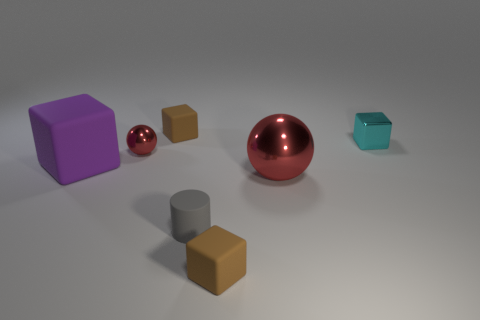Is there any other thing that has the same shape as the gray thing?
Provide a short and direct response. No. How many small brown blocks are both to the left of the cylinder and in front of the large rubber cube?
Offer a terse response. 0. What material is the large ball?
Keep it short and to the point. Metal. Are there an equal number of gray things on the right side of the gray thing and brown matte balls?
Give a very brief answer. Yes. How many other cyan objects are the same shape as the cyan object?
Your response must be concise. 0. Do the tiny gray matte object and the large metal thing have the same shape?
Your response must be concise. No. What number of objects are things that are in front of the small gray thing or big spheres?
Offer a terse response. 2. The purple thing that is to the left of the red metallic object that is left of the small brown thing that is in front of the small cyan object is what shape?
Give a very brief answer. Cube. What is the shape of the gray object that is the same material as the large cube?
Ensure brevity in your answer.  Cylinder. The matte cylinder has what size?
Offer a terse response. Small. 